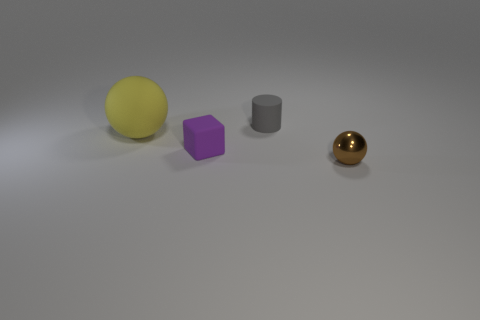Add 4 big yellow rubber blocks. How many objects exist? 8 Subtract all cubes. How many objects are left? 3 Add 3 purple matte objects. How many purple matte objects exist? 4 Subtract 0 purple cylinders. How many objects are left? 4 Subtract all big yellow matte objects. Subtract all tiny gray rubber objects. How many objects are left? 2 Add 2 yellow matte balls. How many yellow matte balls are left? 3 